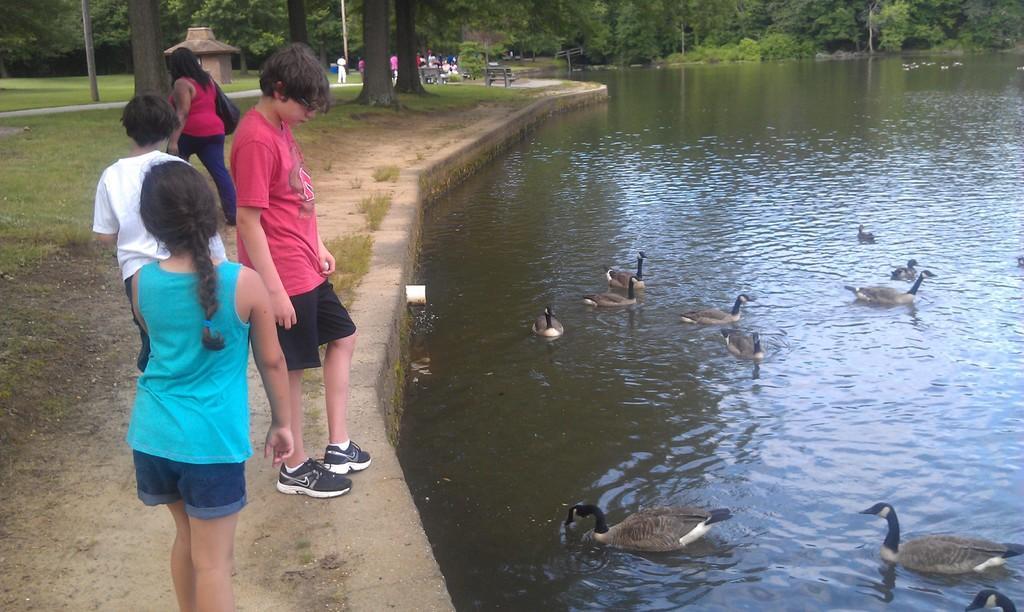Could you give a brief overview of what you see in this image? To the right side of the image there is water and there are ducks. In the background of the image there are trees. In the foreground of the image there are children standing. There is grass. 